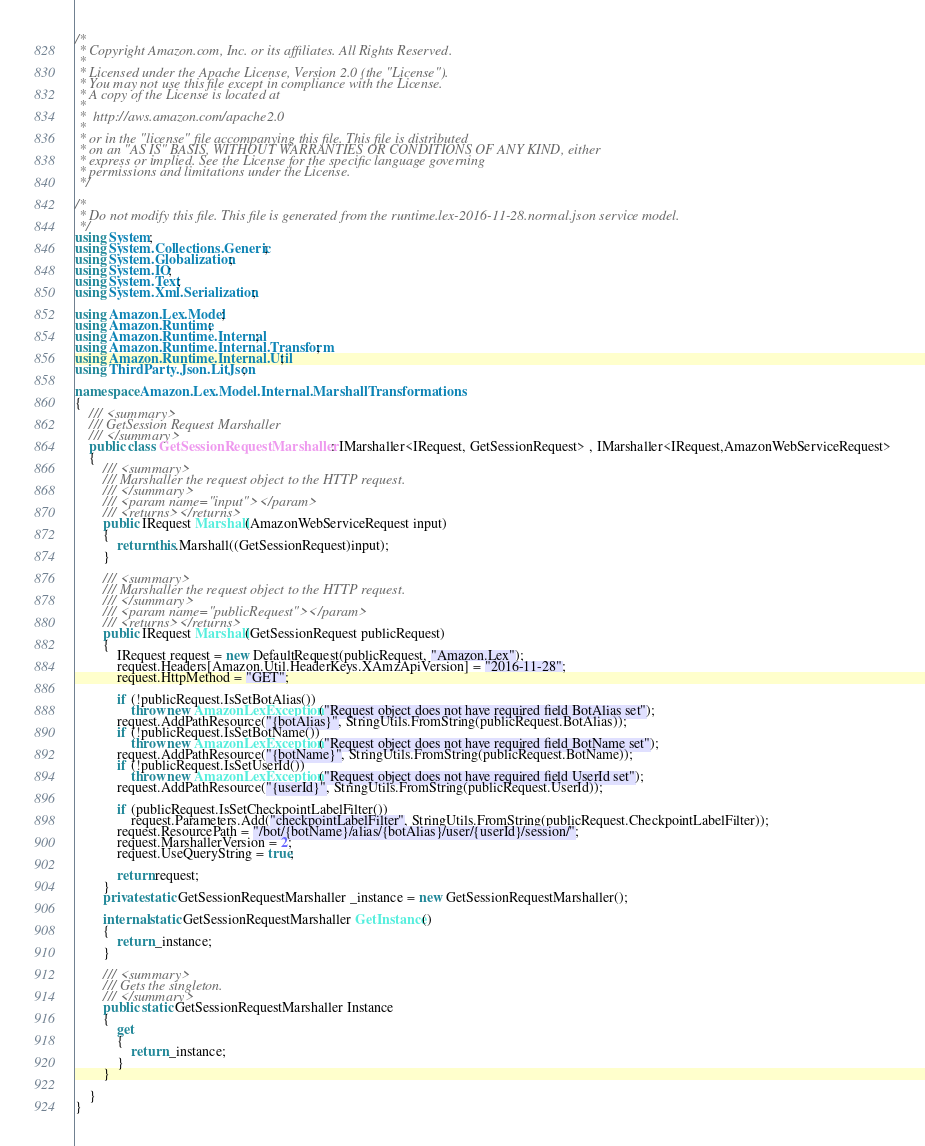<code> <loc_0><loc_0><loc_500><loc_500><_C#_>/*
 * Copyright Amazon.com, Inc. or its affiliates. All Rights Reserved.
 * 
 * Licensed under the Apache License, Version 2.0 (the "License").
 * You may not use this file except in compliance with the License.
 * A copy of the License is located at
 * 
 *  http://aws.amazon.com/apache2.0
 * 
 * or in the "license" file accompanying this file. This file is distributed
 * on an "AS IS" BASIS, WITHOUT WARRANTIES OR CONDITIONS OF ANY KIND, either
 * express or implied. See the License for the specific language governing
 * permissions and limitations under the License.
 */

/*
 * Do not modify this file. This file is generated from the runtime.lex-2016-11-28.normal.json service model.
 */
using System;
using System.Collections.Generic;
using System.Globalization;
using System.IO;
using System.Text;
using System.Xml.Serialization;

using Amazon.Lex.Model;
using Amazon.Runtime;
using Amazon.Runtime.Internal;
using Amazon.Runtime.Internal.Transform;
using Amazon.Runtime.Internal.Util;
using ThirdParty.Json.LitJson;

namespace Amazon.Lex.Model.Internal.MarshallTransformations
{
    /// <summary>
    /// GetSession Request Marshaller
    /// </summary>       
    public class GetSessionRequestMarshaller : IMarshaller<IRequest, GetSessionRequest> , IMarshaller<IRequest,AmazonWebServiceRequest>
    {
        /// <summary>
        /// Marshaller the request object to the HTTP request.
        /// </summary>  
        /// <param name="input"></param>
        /// <returns></returns>
        public IRequest Marshall(AmazonWebServiceRequest input)
        {
            return this.Marshall((GetSessionRequest)input);
        }

        /// <summary>
        /// Marshaller the request object to the HTTP request.
        /// </summary>  
        /// <param name="publicRequest"></param>
        /// <returns></returns>
        public IRequest Marshall(GetSessionRequest publicRequest)
        {
            IRequest request = new DefaultRequest(publicRequest, "Amazon.Lex");
            request.Headers[Amazon.Util.HeaderKeys.XAmzApiVersion] = "2016-11-28";            
            request.HttpMethod = "GET";

            if (!publicRequest.IsSetBotAlias())
                throw new AmazonLexException("Request object does not have required field BotAlias set");
            request.AddPathResource("{botAlias}", StringUtils.FromString(publicRequest.BotAlias));
            if (!publicRequest.IsSetBotName())
                throw new AmazonLexException("Request object does not have required field BotName set");
            request.AddPathResource("{botName}", StringUtils.FromString(publicRequest.BotName));
            if (!publicRequest.IsSetUserId())
                throw new AmazonLexException("Request object does not have required field UserId set");
            request.AddPathResource("{userId}", StringUtils.FromString(publicRequest.UserId));
            
            if (publicRequest.IsSetCheckpointLabelFilter())
                request.Parameters.Add("checkpointLabelFilter", StringUtils.FromString(publicRequest.CheckpointLabelFilter));
            request.ResourcePath = "/bot/{botName}/alias/{botAlias}/user/{userId}/session/";
            request.MarshallerVersion = 2;
            request.UseQueryString = true;

            return request;
        }
        private static GetSessionRequestMarshaller _instance = new GetSessionRequestMarshaller();        

        internal static GetSessionRequestMarshaller GetInstance()
        {
            return _instance;
        }

        /// <summary>
        /// Gets the singleton.
        /// </summary>  
        public static GetSessionRequestMarshaller Instance
        {
            get
            {
                return _instance;
            }
        }

    }
}</code> 